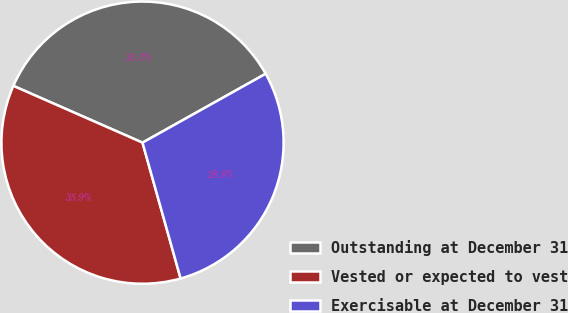<chart> <loc_0><loc_0><loc_500><loc_500><pie_chart><fcel>Outstanding at December 31<fcel>Vested or expected to vest<fcel>Exercisable at December 31<nl><fcel>35.29%<fcel>35.94%<fcel>28.76%<nl></chart> 